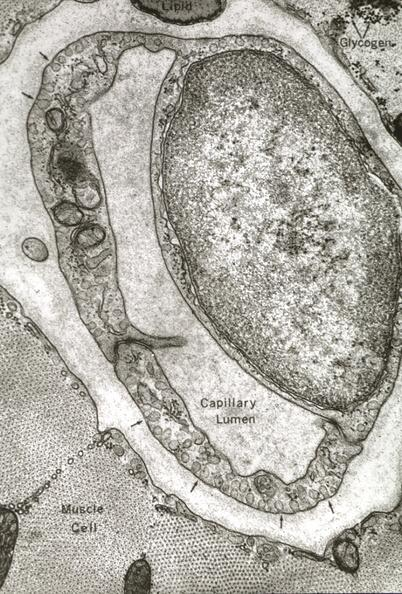s vasculature present?
Answer the question using a single word or phrase. Yes 